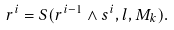<formula> <loc_0><loc_0><loc_500><loc_500>r ^ { i } = S ( r ^ { i - 1 } \wedge s ^ { i } , l , M _ { k } ) .</formula> 